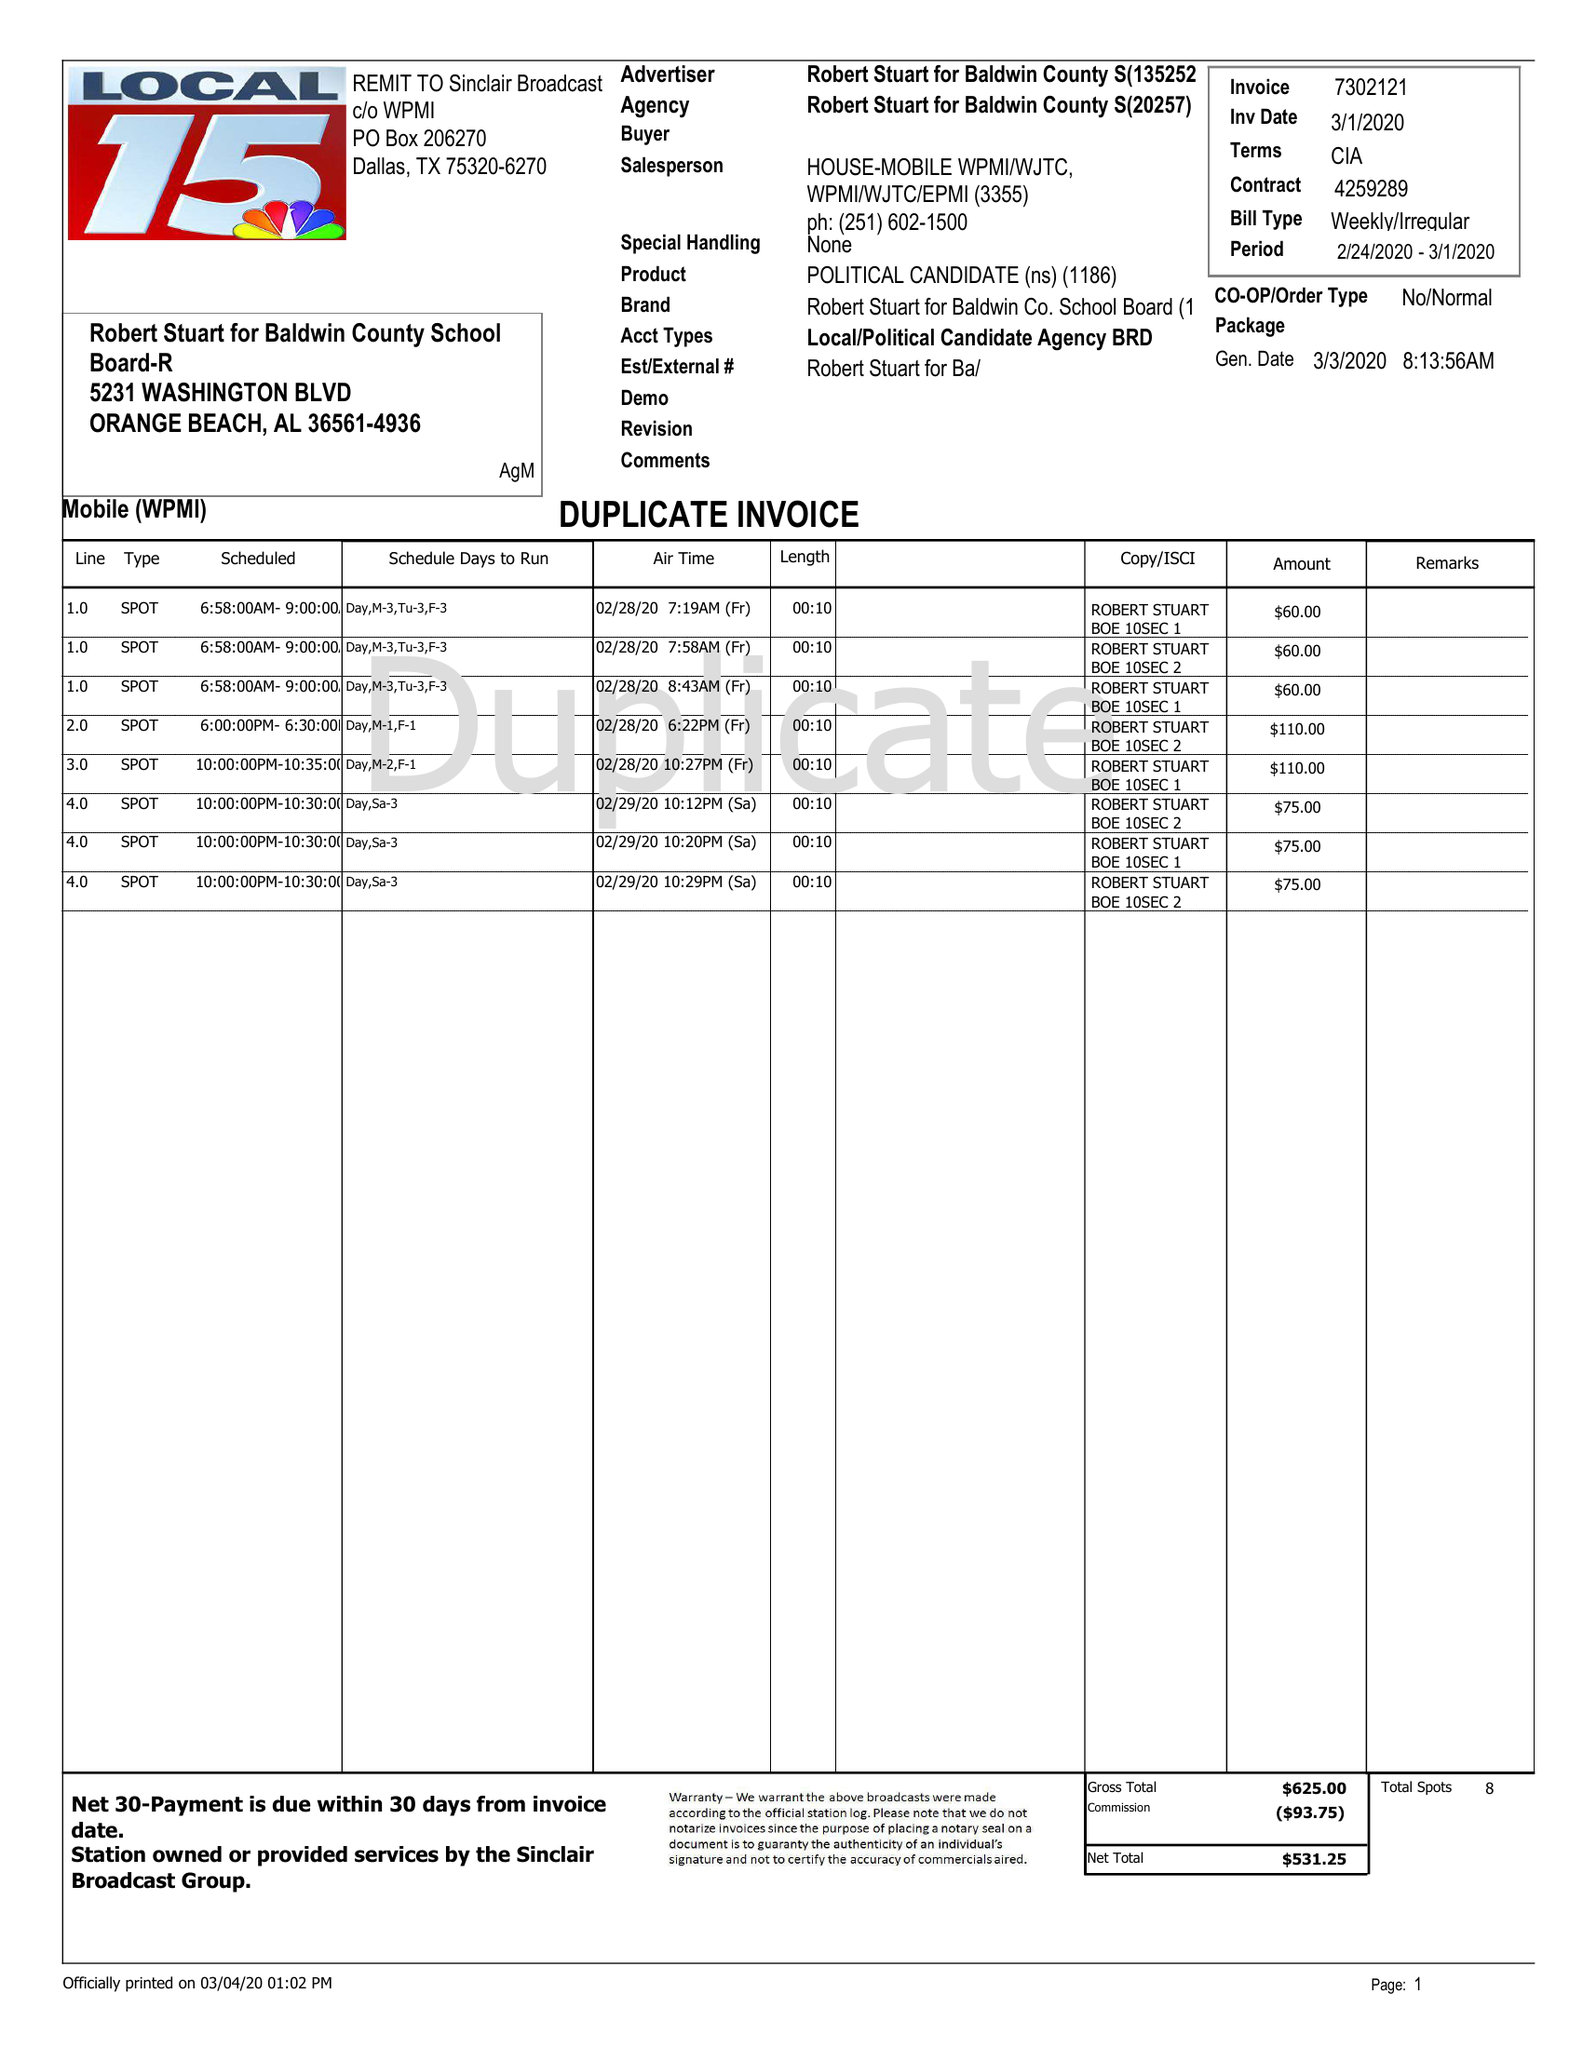What is the value for the advertiser?
Answer the question using a single word or phrase. ROBERT STUART FOR BALDWIN COUNTY S 